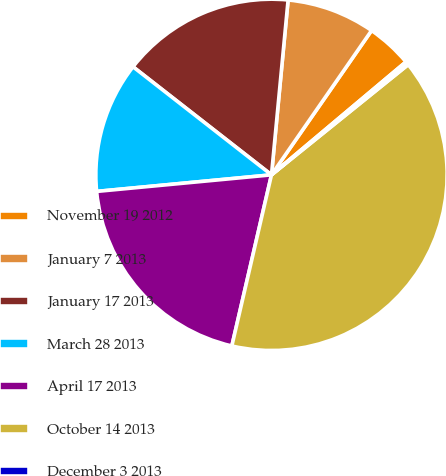Convert chart. <chart><loc_0><loc_0><loc_500><loc_500><pie_chart><fcel>November 19 2012<fcel>January 7 2013<fcel>January 17 2013<fcel>March 28 2013<fcel>April 17 2013<fcel>October 14 2013<fcel>December 3 2013<nl><fcel>4.23%<fcel>8.14%<fcel>15.96%<fcel>12.05%<fcel>19.87%<fcel>39.42%<fcel>0.32%<nl></chart> 